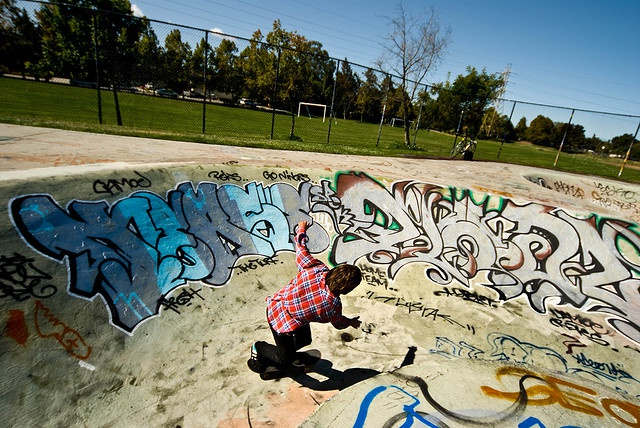Describe the objects in this image and their specific colors. I can see people in gray, black, lightgray, maroon, and lightpink tones, skateboard in gray, black, and tan tones, car in gray, black, blue, and darkgreen tones, and car in gray, black, white, and darkblue tones in this image. 